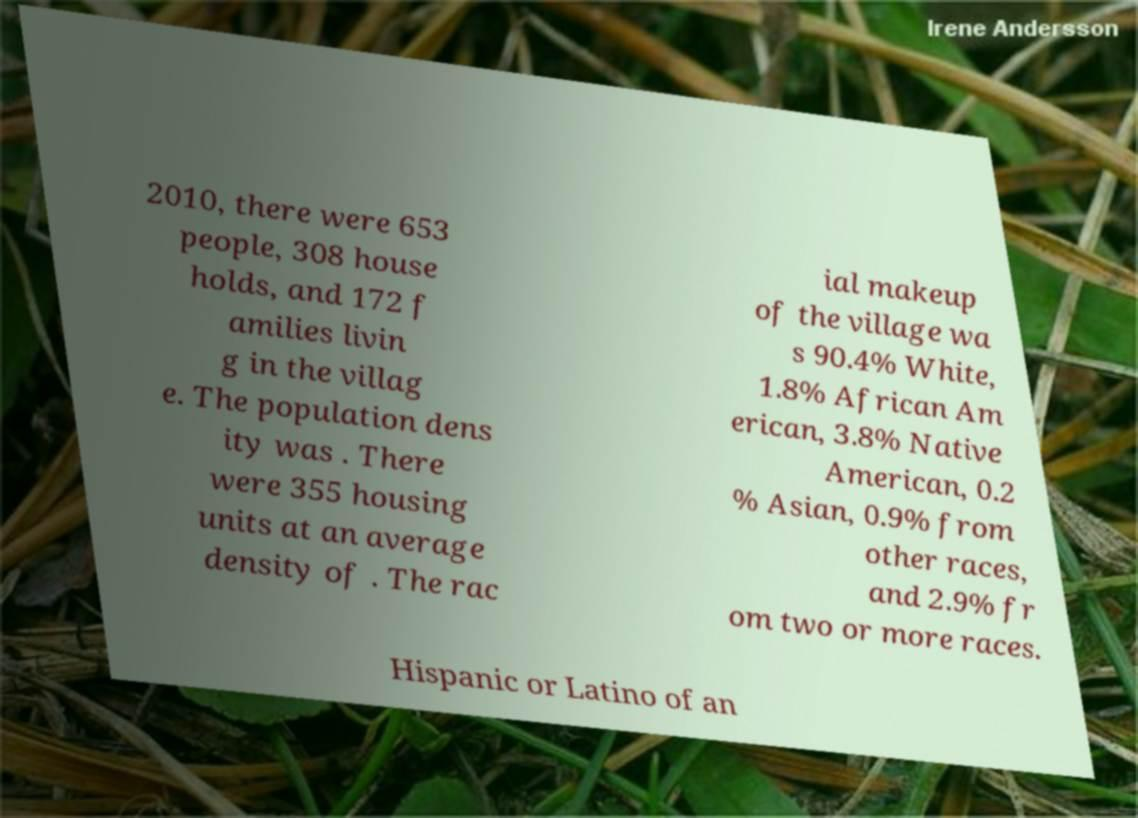There's text embedded in this image that I need extracted. Can you transcribe it verbatim? 2010, there were 653 people, 308 house holds, and 172 f amilies livin g in the villag e. The population dens ity was . There were 355 housing units at an average density of . The rac ial makeup of the village wa s 90.4% White, 1.8% African Am erican, 3.8% Native American, 0.2 % Asian, 0.9% from other races, and 2.9% fr om two or more races. Hispanic or Latino of an 